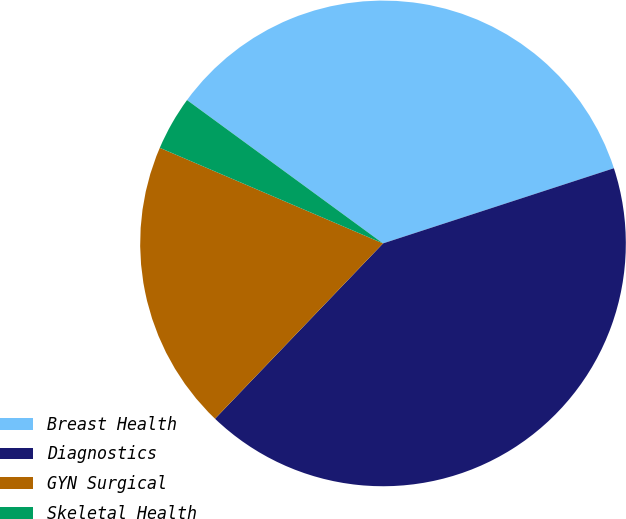Convert chart. <chart><loc_0><loc_0><loc_500><loc_500><pie_chart><fcel>Breast Health<fcel>Diagnostics<fcel>GYN Surgical<fcel>Skeletal Health<nl><fcel>34.94%<fcel>42.17%<fcel>19.28%<fcel>3.61%<nl></chart> 